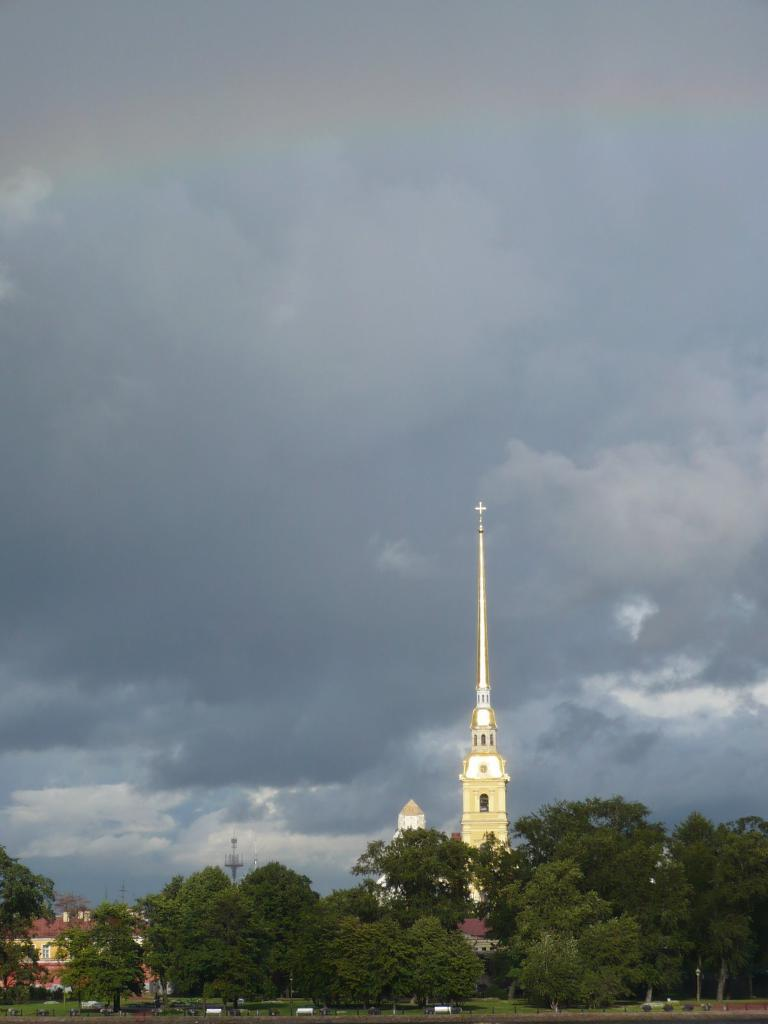What type of natural elements are present in the image? There are many trees in the image. What type of man-made structures can be seen near the trees? There are buildings and a tower near the trees. What can be seen in the background of the image? There are clouds and the sky visible in the background of the image. What type of news can be heard coming from the tower in the image? There is no indication in the image that the tower is broadcasting news or any other type of information. 